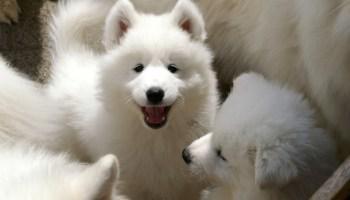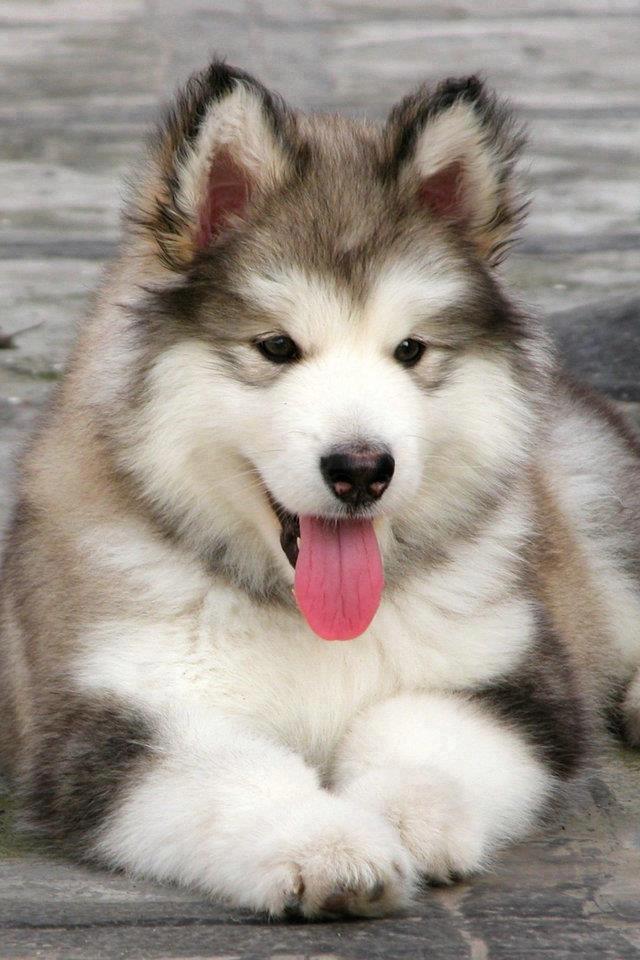The first image is the image on the left, the second image is the image on the right. For the images displayed, is the sentence "The left and right image contains the same number of dogs." factually correct? Answer yes or no. No. The first image is the image on the left, the second image is the image on the right. For the images displayed, is the sentence "A dog is standing in the grass." factually correct? Answer yes or no. No. 